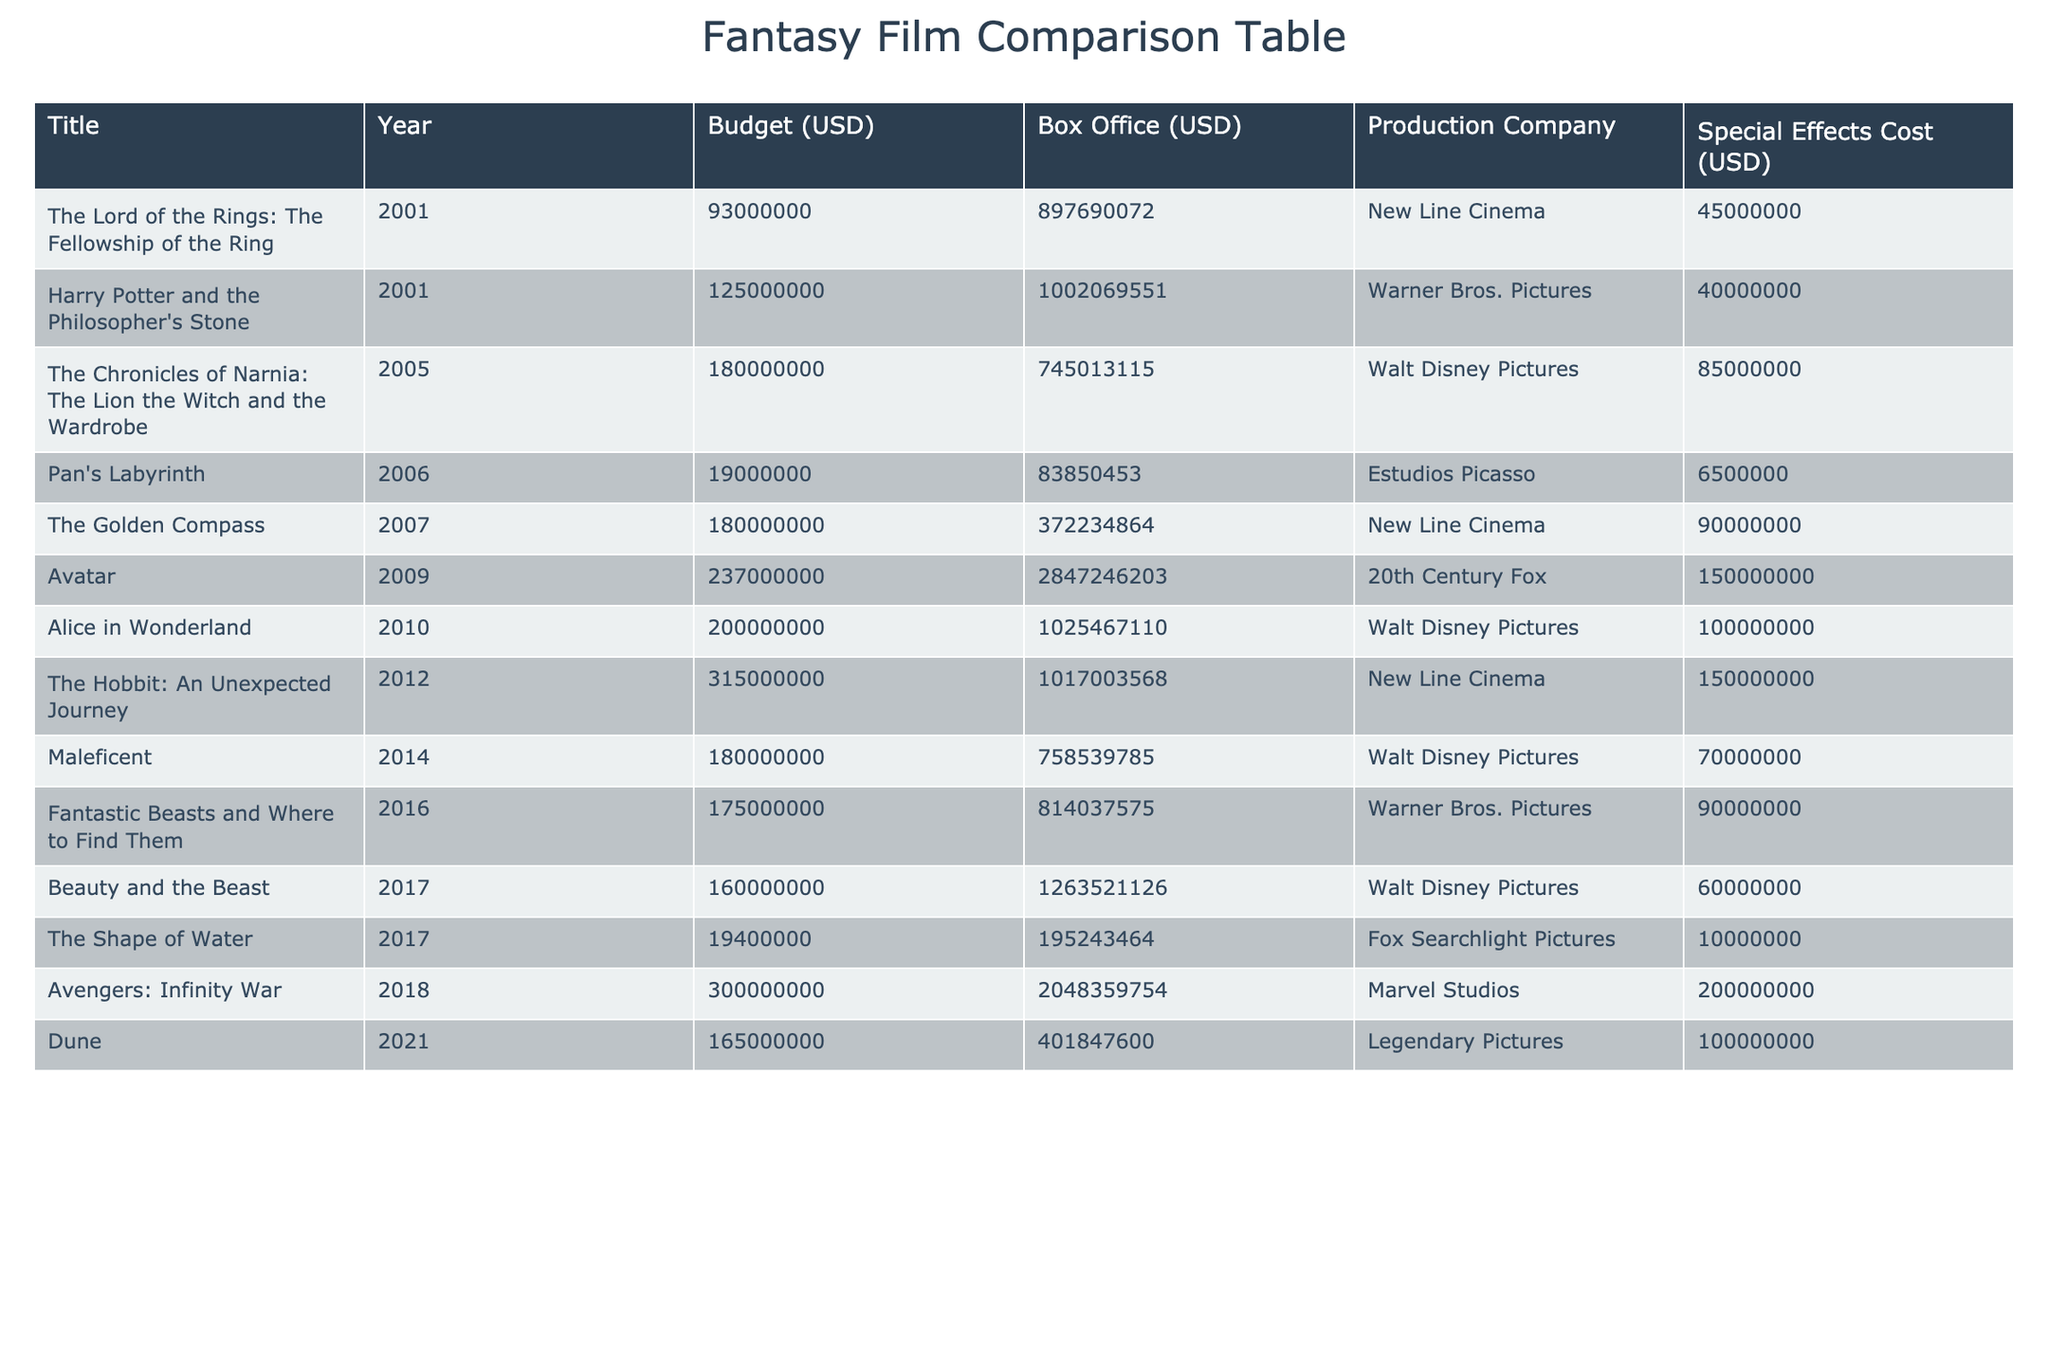What is the highest production budget among the films listed? From the table, I will check the "Budget (USD)" column for the highest value. The film "The Hobbit: An Unexpected Journey" has a production budget of 315000000 USD, which is the highest in this table.
Answer: 315000000 USD Which film had the lowest box office revenue? I will look through the "Box Office (USD)" column for the lowest figure. "Pan's Labyrinth" shows a box office revenue of 83850453 USD, which is the lowest among all films listed.
Answer: 83850453 USD How much more did "Avatar" make at the box office compared to "The Golden Compass"? The box office revenue for "Avatar" is 2847246203 USD, and for "The Golden Compass," it is 372234864 USD. The difference is calculated as 2847246203 - 372234864 = 2475011349 USD.
Answer: 2475011349 USD What percentage of the budget did "Alice in Wonderland" allocate to special effects? First, I will find the budget of "Alice in Wonderland," which is 200000000 USD. The special effects cost for the film is 100000000 USD. To find the percentage, I will use the formula (special effects cost / budget) * 100 = (100000000 / 200000000) * 100 = 50%.
Answer: 50% Is it true that all films listed had a box office revenue over 500 million USD? I will review the "Box Office (USD)" column to verify this claim. The film "Pan's Labyrinth" only earned 83850453 USD, which is less than 500 million USD. Thus, the statement is false.
Answer: No Which film produced by Warner Bros. Pictures had the highest box office return? Looking at the "Production Company" and "Box Office (USD)" columns, "Harry Potter and the Philosopher's Stone" was produced by Warner Bros. Pictures and had a box office of 1002069551 USD. The other Warner Bros. film is "Fantastic Beasts and Where to Find Them," which had 814037575 USD. Therefore, the highest box office return for Warner Bros. is from "Harry Potter and the Philosopher's Stone."
Answer: Harry Potter and the Philosopher's Stone What is the average budget of all films released from 2001 to 2010? To find the average, I'll sum the budgets of films from 2001 (93000000 and 125000000) to 2010 (200000000). The total budget is 93000000 + 125000000 + 180000000 + 19000000 + 180000000 + 237000000 + 200000000 = 1055000000 USD. Since there are 7 films, the average budget is 1055000000 / 7 = 150714285.71 USD.
Answer: 150714286 USD How many films have a special effects cost greater than 80000000 USD? I will check the "Special Effects Cost (USD)" column. The films "The Chronicles of Narnia: The Lion the Witch and the Wardrobe," "The Golden Compass," "Avatar," "Alice in Wonderland," "The Hobbit: An Unexpected Journey," and "Fantastic Beasts and Where to Find Them" all have special effects costs above 80000000 USD. Counting these, there are 6 films.
Answer: 6 